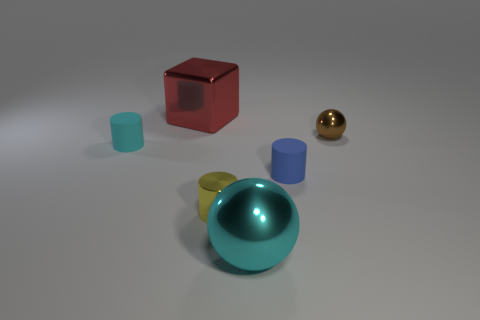Add 3 large brown matte things. How many objects exist? 9 Subtract all yellow shiny cylinders. How many cylinders are left? 2 Subtract 1 cylinders. How many cylinders are left? 2 Subtract all cubes. How many objects are left? 5 Subtract all red cylinders. Subtract all gray cubes. How many cylinders are left? 3 Add 6 small metal objects. How many small metal objects are left? 8 Add 5 blocks. How many blocks exist? 6 Subtract 0 blue balls. How many objects are left? 6 Subtract all blue rubber cubes. Subtract all cylinders. How many objects are left? 3 